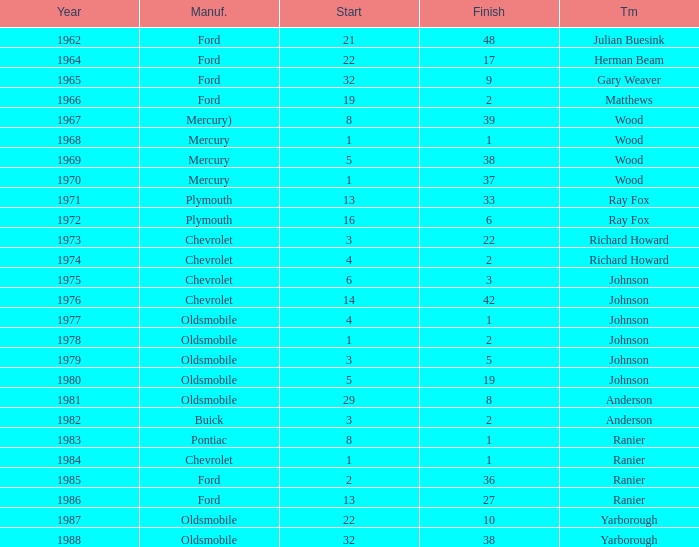What is the smallest finish time for a race after 1972 with a car manufactured by pontiac? 1.0. 